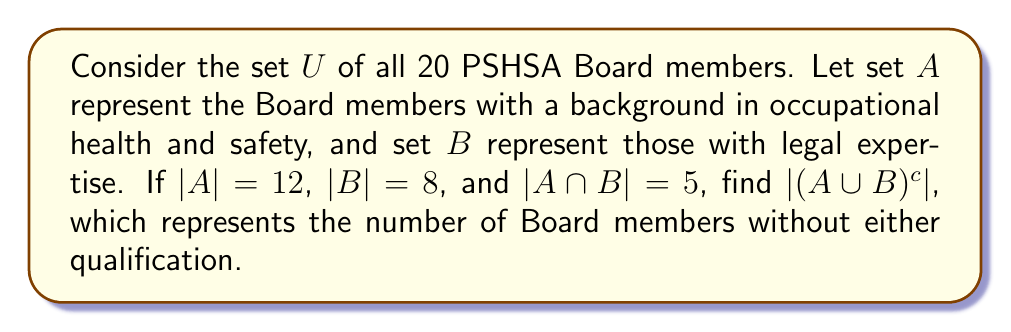Could you help me with this problem? To solve this problem, we'll follow these steps:

1. Calculate $|A \cup B|$ using the inclusion-exclusion principle:
   $$|A \cup B| = |A| + |B| - |A \cap B|$$
   $$|A \cup B| = 12 + 8 - 5 = 15$$

2. Recall that the complement of a set $X$ in a universal set $U$ is given by:
   $$|X^c| = |U| - |X|$$

3. In this case, we want to find $|(A \cup B)^c|$:
   $$|(A \cup B)^c| = |U| - |A \cup B|$$

4. We know that $|U| = 20$ (total number of Board members) and we calculated $|A \cup B| = 15$:
   $$|(A \cup B)^c| = 20 - 15 = 5$$

This result represents the number of Board members who have neither a background in occupational health and safety nor legal expertise.
Answer: $|(A \cup B)^c| = 5$ 